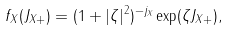<formula> <loc_0><loc_0><loc_500><loc_500>f _ { X } ( J _ { X + } ) = ( 1 + | \zeta | ^ { 2 } ) ^ { - j _ { X } } \exp ( \zeta J _ { X + } ) ,</formula> 